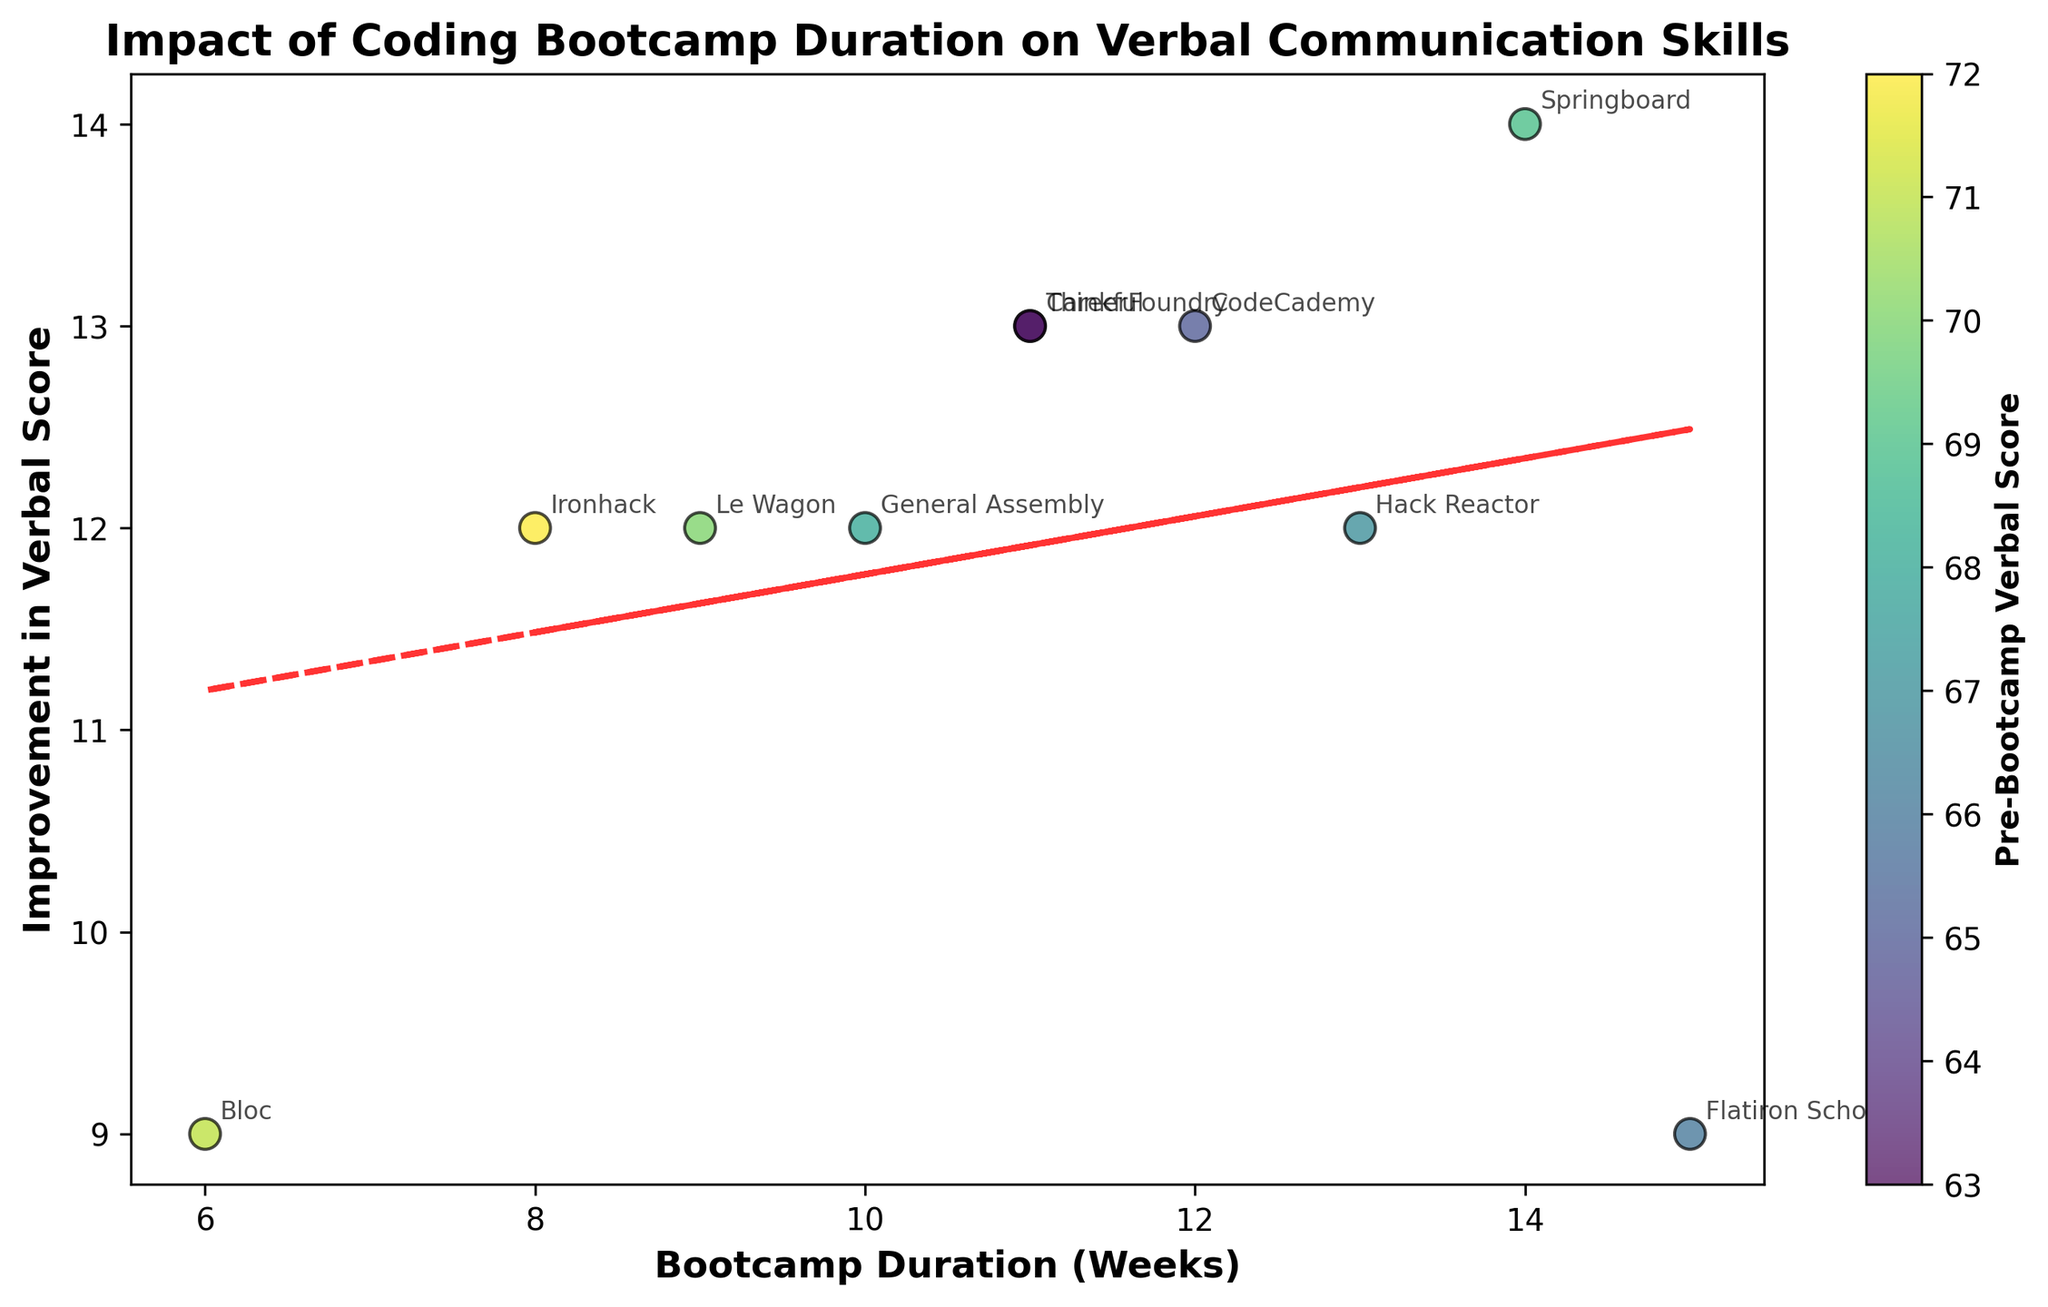What's the title of the figure? The title of the figure is displayed prominently above the main plot area. It provides a summary of what the plot represents.
Answer: Impact of Coding Bootcamp Duration on Verbal Communication Skills How many data points are represented on the scatter plot? There are as many data points as there are different bootcamp entries. By counting them, we can determine the number of points shown.
Answer: 10 Which bootcamp had the highest improvement in verbal score? To find the bootcamp with the highest improvement, look for the data point that is located highest on the y-axis. The label near this point will indicate the bootcamp.
Answer: Ironhack What does the color of the data points represent? The color of the data points represents the pre-bootcamp verbal scores. This is indicated by the colorbar on the right side of the plot.
Answer: Pre-Bootcamp Verbal Score What is the range of the x-axis values? The x-axis represents the bootcamp duration in weeks. By looking at the minimum and maximum values along this axis, we can determine the range.
Answer: 6-15 weeks Which two bootcamps have the same duration but different improvements in verbal score? By identifying bootcamps with the same x-axis value and comparing their y-axis values, we can find those with the same duration but different improvements.
Answer: Thinkful and CareerFoundry What can you infer from the trend line's slope about the relationship between bootcamp duration and verbal score improvement? The slope of the trend line shows the general direction of the relationship. If the slope is positive, bootcamp duration is positively correlated with verbal score improvement; if negative, the correlation is negative.
Answer: Positive correlation What is the approximate improvement in verbal score for a bootcamp that lasts 10 weeks based on the trend line? By locating the value at 10 weeks on the x-axis and finding the corresponding y-value on the trend line, we can approximate the improvement.
Answer: Around 12 points If a bootcamp lasted 14 weeks, approximately what pre-bootcamp verbal score would be predictive of around an 18-point improvement based on the color and position of the scatter points? Locate the data point near the 14-week mark with an approximate 18-point improvement and refer to its color, which correlates with the pre-bootcamp score as shown on the colorbar.
Answer: Around 69 How does Springboard's verbal score improvement compare to that of Bloc in terms of both size and pre-bootcamp score? Check the y-axis value for Springboard versus Bloc to compare improvements and observe their colors to compare pre-bootcamp scores.
Answer: Springboard improved more and had a higher pre-bootcamp score than Bloc 